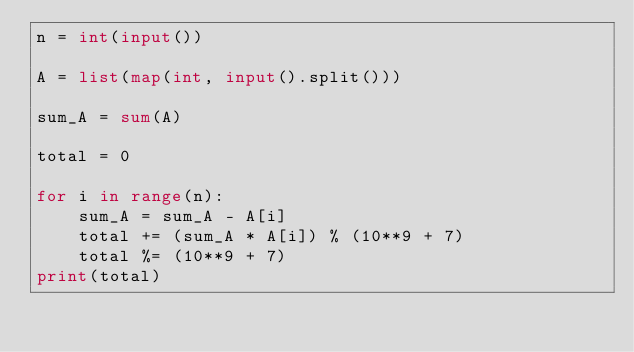Convert code to text. <code><loc_0><loc_0><loc_500><loc_500><_Python_>n = int(input())

A = list(map(int, input().split()))

sum_A = sum(A)

total = 0

for i in range(n):
    sum_A = sum_A - A[i]
    total += (sum_A * A[i]) % (10**9 + 7)
    total %= (10**9 + 7)
print(total)</code> 